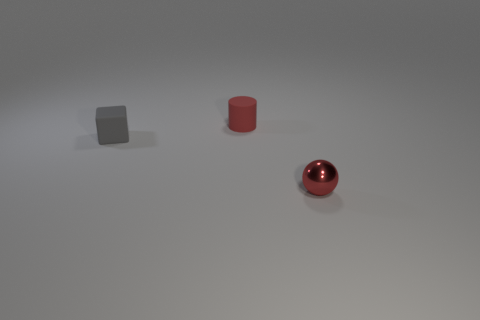Add 3 tiny red metal balls. How many objects exist? 6 Subtract all balls. How many objects are left? 2 Subtract all small purple shiny balls. Subtract all small cubes. How many objects are left? 2 Add 2 matte cylinders. How many matte cylinders are left? 3 Add 3 matte objects. How many matte objects exist? 5 Subtract 0 gray cylinders. How many objects are left? 3 